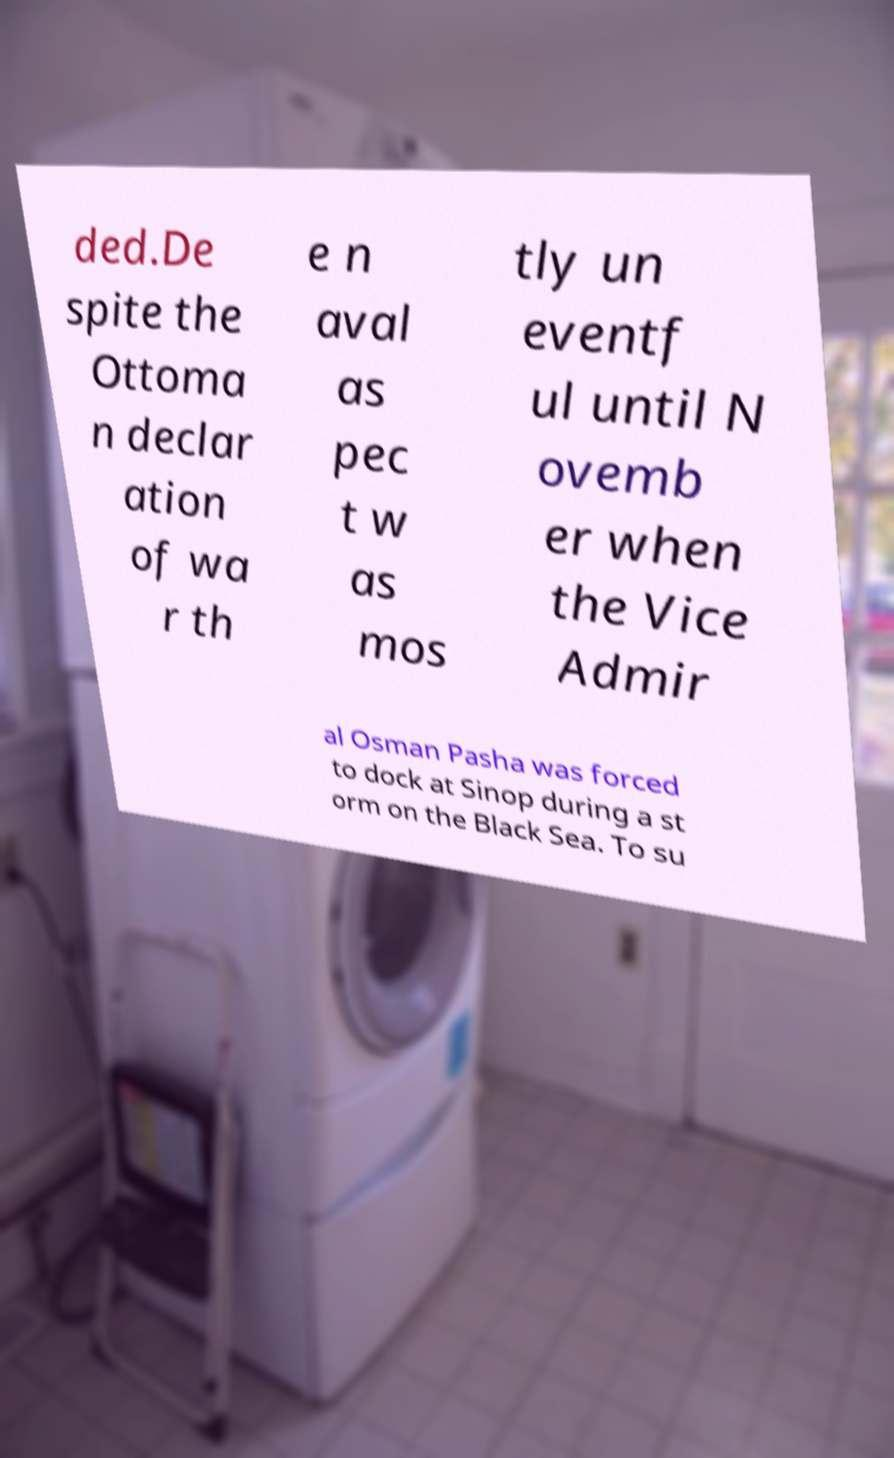Please identify and transcribe the text found in this image. ded.De spite the Ottoma n declar ation of wa r th e n aval as pec t w as mos tly un eventf ul until N ovemb er when the Vice Admir al Osman Pasha was forced to dock at Sinop during a st orm on the Black Sea. To su 